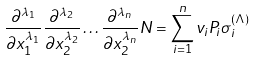Convert formula to latex. <formula><loc_0><loc_0><loc_500><loc_500>\frac { \partial ^ { \lambda _ { 1 } } } { \partial x _ { 1 } ^ { \lambda _ { 1 } } } \frac { \partial ^ { \lambda _ { 2 } } } { \partial x _ { 2 } ^ { \lambda _ { 2 } } } \dots \frac { \partial ^ { \lambda _ { n } } } { \partial x _ { 2 } ^ { \lambda _ { n } } } N = \sum _ { i = 1 } ^ { n } v _ { i } P _ { i } \sigma _ { i } ^ { ( \Lambda ) }</formula> 